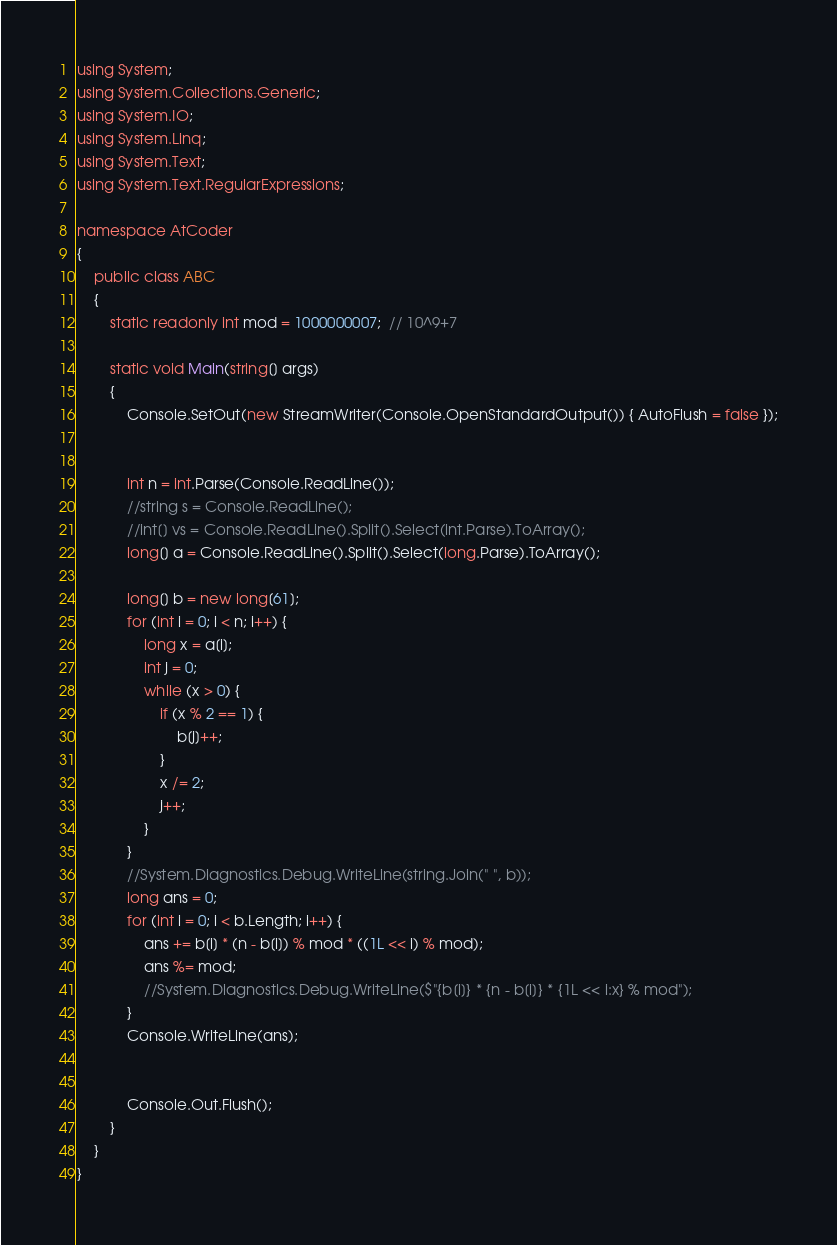<code> <loc_0><loc_0><loc_500><loc_500><_C#_>using System;
using System.Collections.Generic;
using System.IO;
using System.Linq;
using System.Text;
using System.Text.RegularExpressions;

namespace AtCoder
{
	public class ABC
	{
		static readonly int mod = 1000000007;  // 10^9+7

		static void Main(string[] args)
		{
			Console.SetOut(new StreamWriter(Console.OpenStandardOutput()) { AutoFlush = false });


			int n = int.Parse(Console.ReadLine());
			//string s = Console.ReadLine();
			//int[] vs = Console.ReadLine().Split().Select(int.Parse).ToArray();
			long[] a = Console.ReadLine().Split().Select(long.Parse).ToArray();

			long[] b = new long[61];
			for (int i = 0; i < n; i++) {
				long x = a[i];
				int j = 0;
				while (x > 0) {
					if (x % 2 == 1) {
						b[j]++;
					}
					x /= 2;
					j++;
				}
			}
			//System.Diagnostics.Debug.WriteLine(string.Join(" ", b));
			long ans = 0;
			for (int i = 0; i < b.Length; i++) {
				ans += b[i] * (n - b[i]) % mod * ((1L << i) % mod);
				ans %= mod;
				//System.Diagnostics.Debug.WriteLine($"{b[i]} * {n - b[i]} * {1L << i:x} % mod");
			}
			Console.WriteLine(ans);


			Console.Out.Flush();
		}
	}
}
</code> 